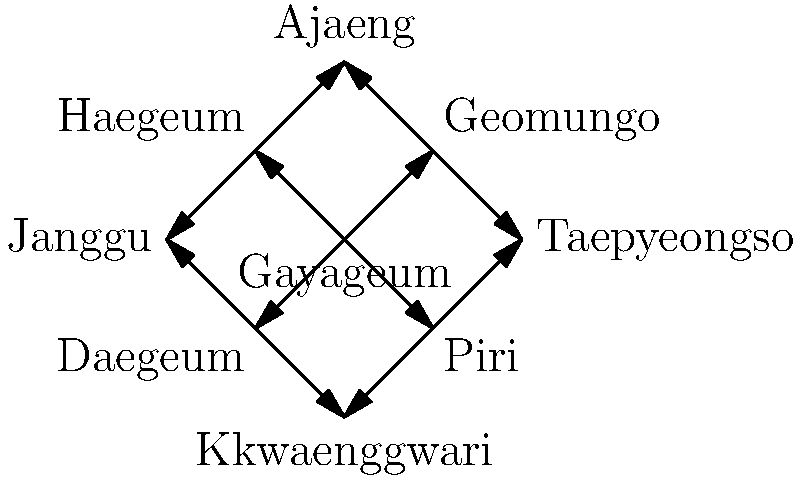Based on the network graph of traditional Korean musical instruments, which instrument has the highest degree centrality (i.e., the most direct connections to other instruments)? To determine the instrument with the highest degree centrality, we need to count the number of direct connections (edges) for each instrument in the network:

1. Gayageum: 4 connections (to Geomungo, Haegeum, Daegeum, and Piri)
2. Geomungo: 3 connections (to Gayageum, Ajaeng, and Taepyeongso)
3. Haegeum: 3 connections (to Gayageum, Ajaeng, and Janggu)
4. Daegeum: 3 connections (to Gayageum, Janggu, and Kkwaenggwari)
5. Piri: 3 connections (to Gayageum, Taepyeongso, and Kkwaenggwari)
6. Ajaeng: 2 connections (to Geomungo and Haegeum)
7. Taepyeongso: 2 connections (to Geomungo and Piri)
8. Janggu: 2 connections (to Haegeum and Daegeum)
9. Kkwaenggwari: 2 connections (to Daegeum and Piri)

The instrument with the highest number of direct connections is the Gayageum, with 4 connections.
Answer: Gayageum 